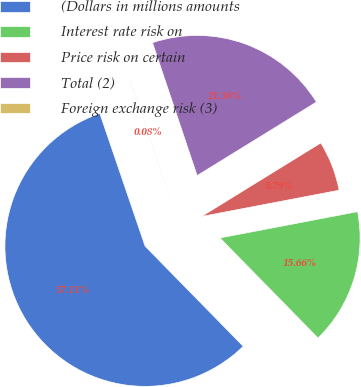Convert chart to OTSL. <chart><loc_0><loc_0><loc_500><loc_500><pie_chart><fcel>(Dollars in millions amounts<fcel>Interest rate risk on<fcel>Price risk on certain<fcel>Total (2)<fcel>Foreign exchange risk (3)<nl><fcel>57.1%<fcel>15.66%<fcel>5.79%<fcel>21.36%<fcel>0.08%<nl></chart> 